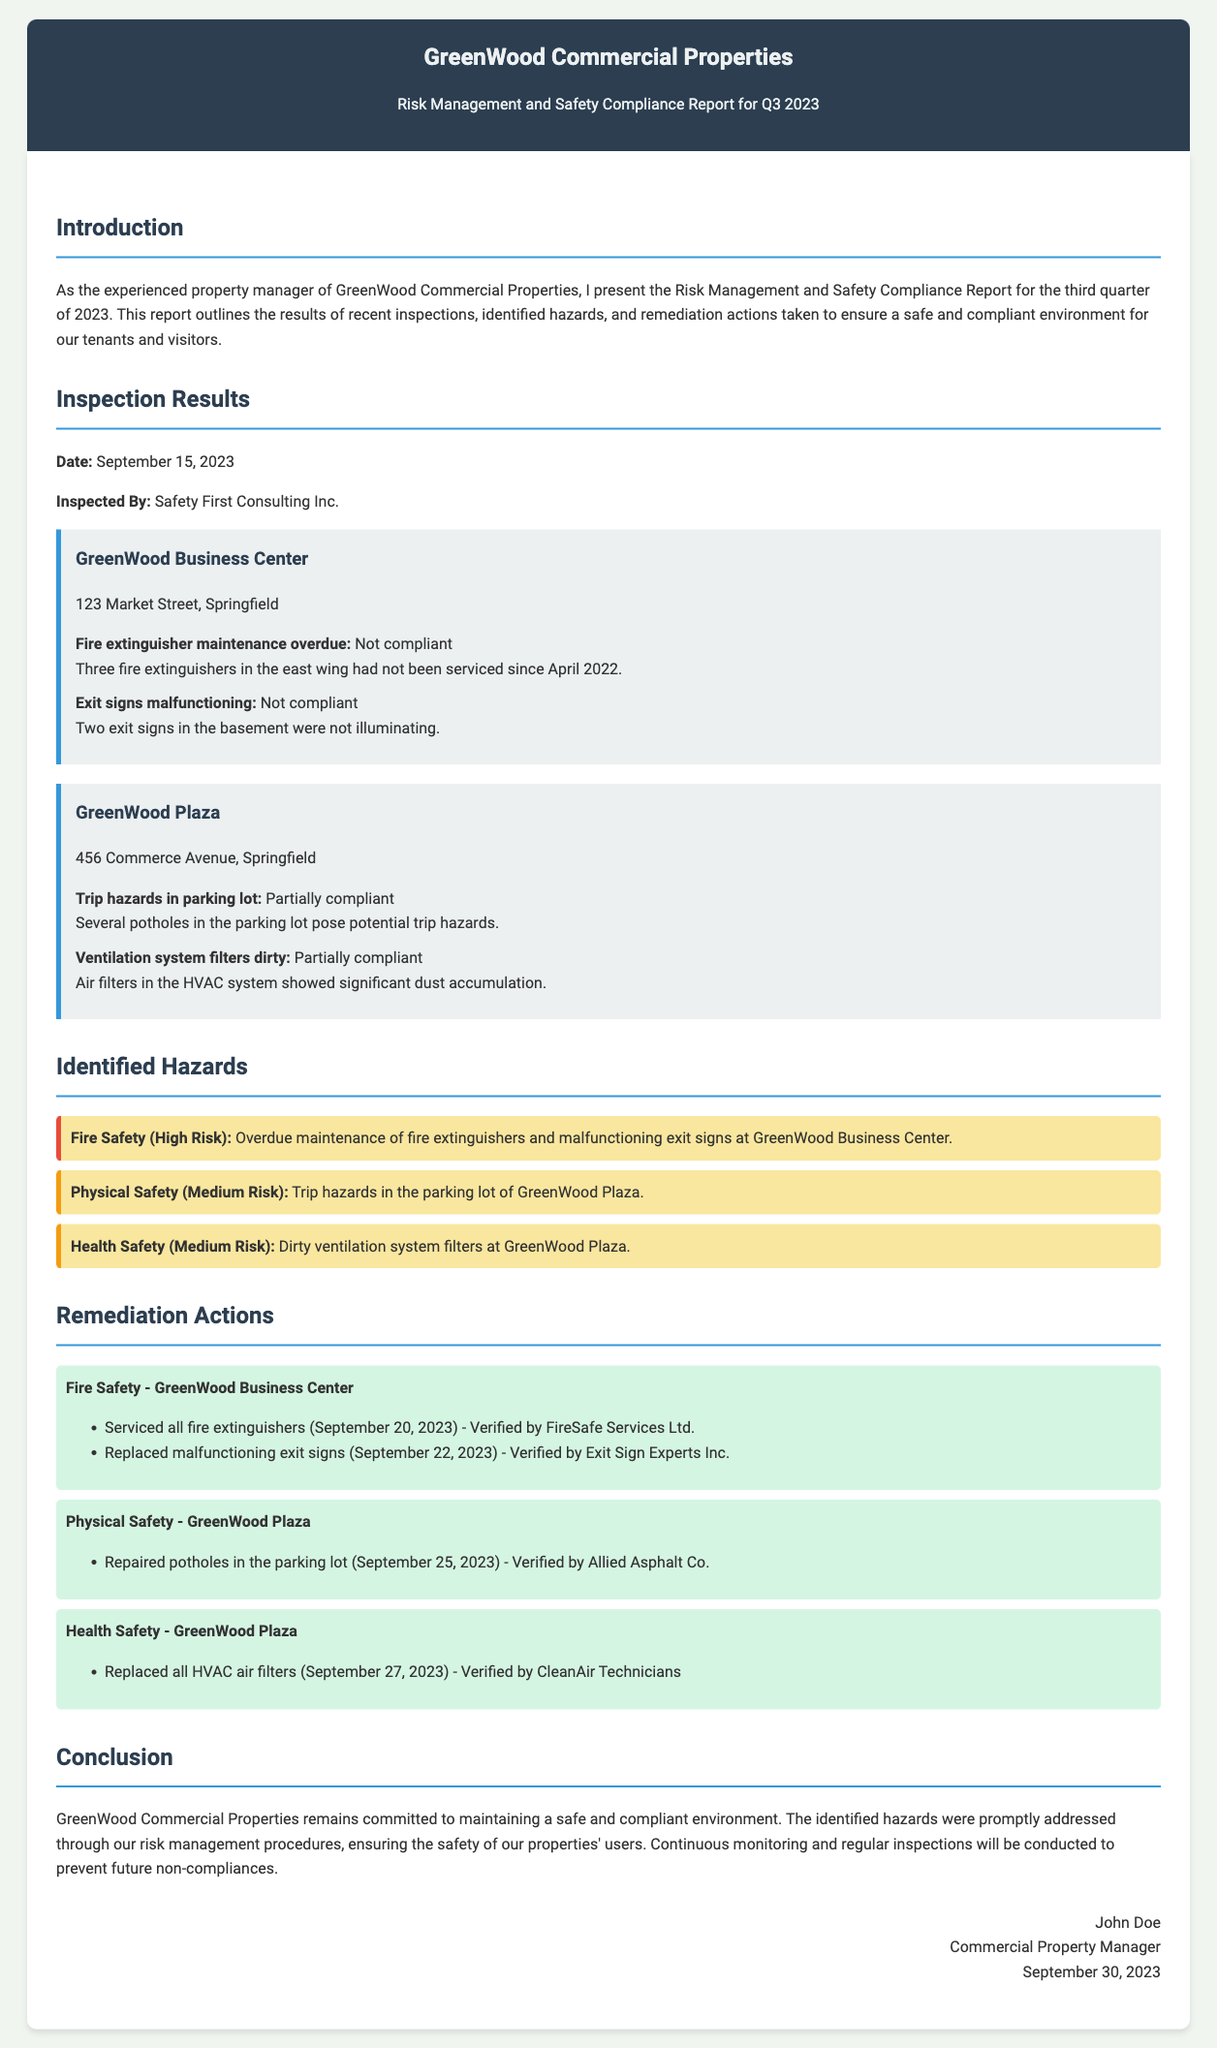What is the date of the inspection? The date of the inspection is provided in the Inspection Results section of the document.
Answer: September 15, 2023 Who conducted the inspection? The document states that Safety First Consulting Inc. was responsible for the inspection.
Answer: Safety First Consulting Inc How many properties were inspected? The document lists two properties in the Inspection Results section.
Answer: Two What was identified as a high-risk hazard? The document specifically mentions overdue maintenance of fire extinguishers as a high-risk hazard.
Answer: Fire Safety What remediation action was taken at GreenWood Business Center? The document describes servicing of fire extinguishers and replacing malfunctioning exit signs as actions taken.
Answer: Serviced fire extinguishers and replaced exit signs What was discovered in the parking lot of GreenWood Plaza? The document states that several potholes in the parking lot posed potential trip hazards.
Answer: Trip hazards When were the HVAC air filters replaced? The document mentions the date when the HVAC air filters were replaced in the Remediation Actions section.
Answer: September 27, 2023 What is the main purpose of this report? The introduction outlines the report's aim to present inspection results, identified hazards, and remediation actions for safety compliance.
Answer: Safety compliance Who is the author of the report? The author is listed at the end of the document in the signature section.
Answer: John Doe 